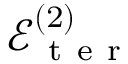<formula> <loc_0><loc_0><loc_500><loc_500>\mathcal { E } _ { t e r } ^ { ( 2 ) }</formula> 